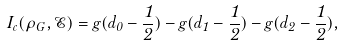<formula> <loc_0><loc_0><loc_500><loc_500>I _ { c } ( \rho _ { G } , \mathcal { E } ) = g ( d _ { 0 } - \frac { 1 } { 2 } ) - g ( d _ { 1 } - \frac { 1 } { 2 } ) - g ( d _ { 2 } - \frac { 1 } { 2 } ) ,</formula> 